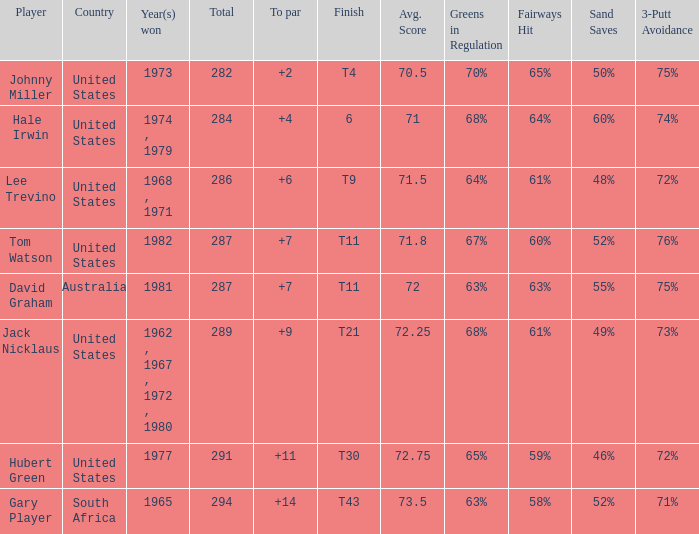WHAT IS THE TOTAL THAT HAS A WIN IN 1982? 287.0. 